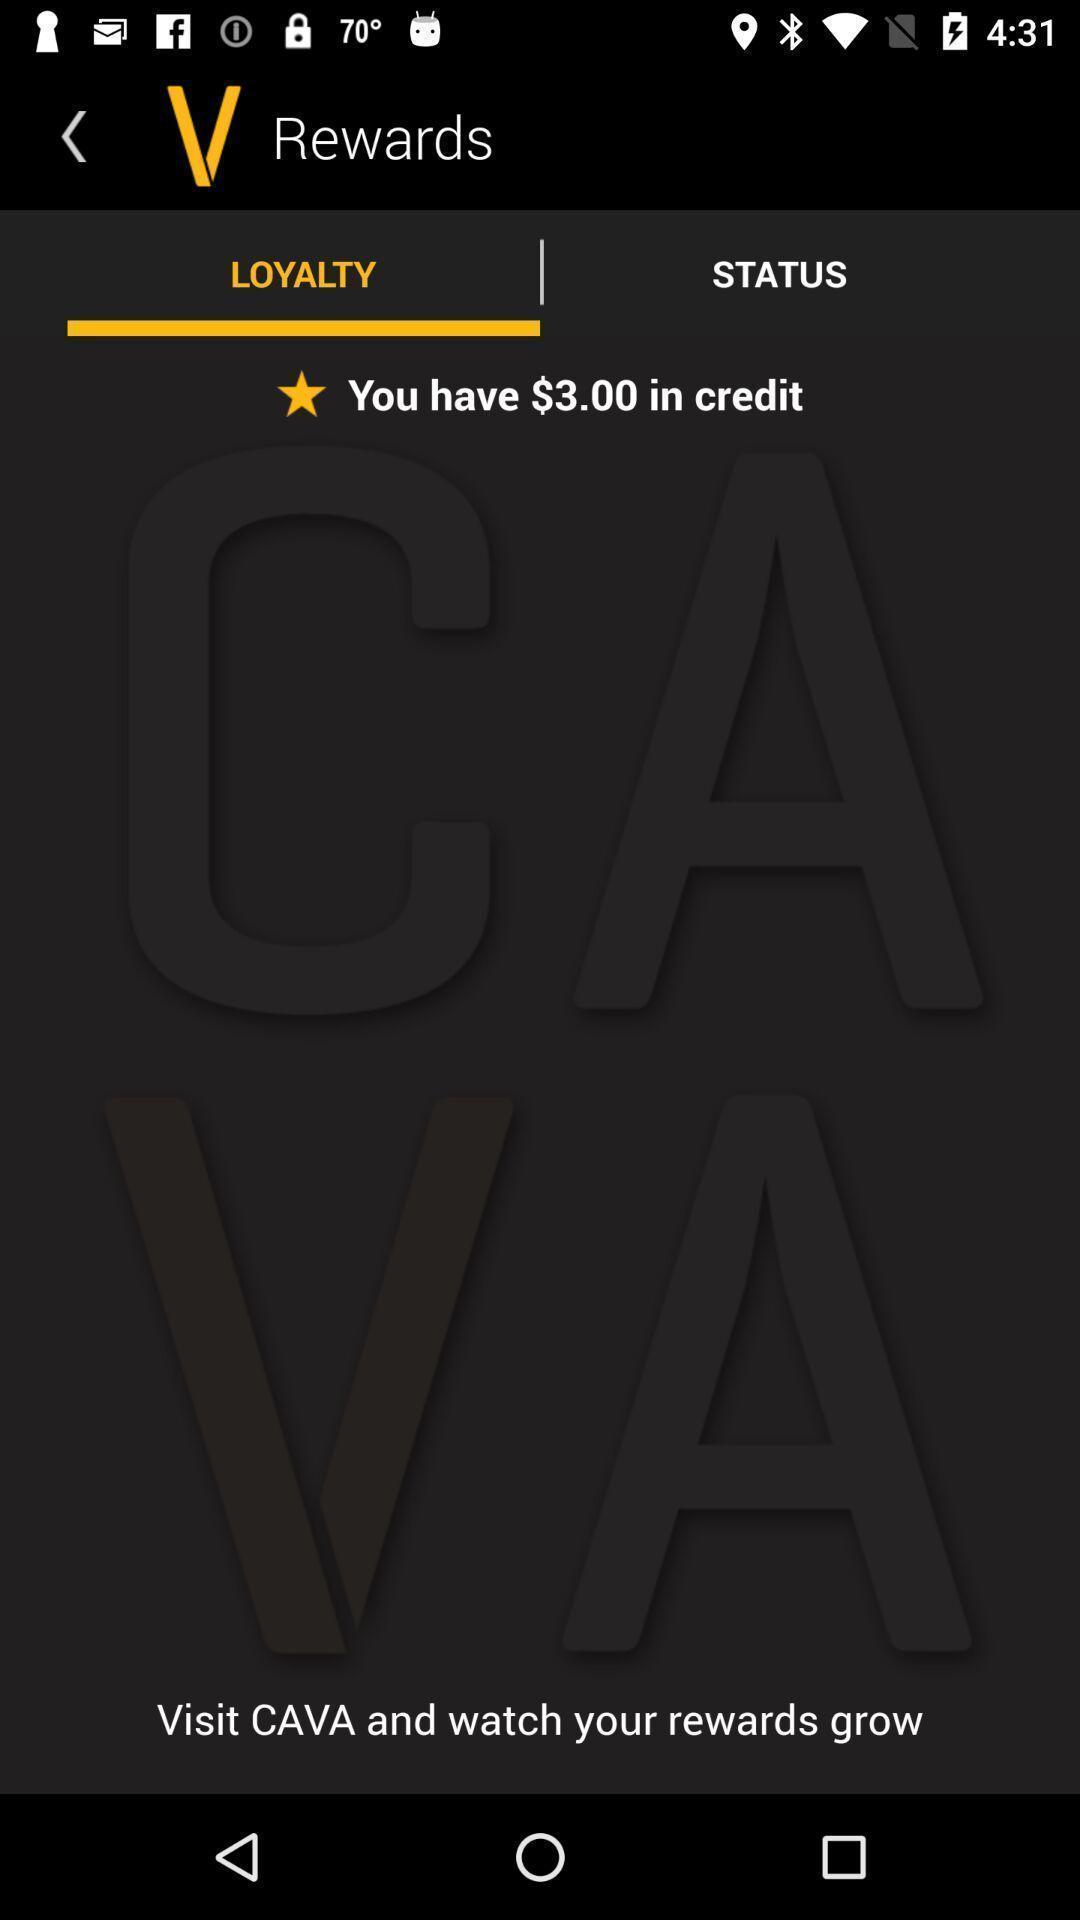Describe the key features of this screenshot. Screen showing loyalty. 